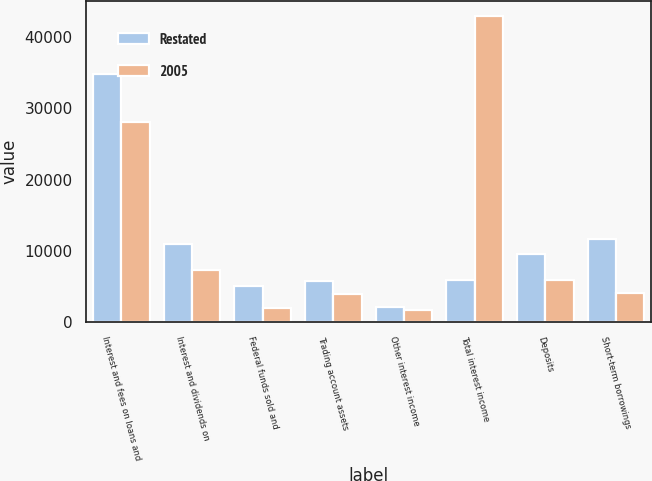<chart> <loc_0><loc_0><loc_500><loc_500><stacked_bar_chart><ecel><fcel>Interest and fees on loans and<fcel>Interest and dividends on<fcel>Federal funds sold and<fcel>Trading account assets<fcel>Other interest income<fcel>Total interest income<fcel>Deposits<fcel>Short-term borrowings<nl><fcel>Restated<fcel>34843<fcel>10937<fcel>5012<fcel>5743<fcel>2091<fcel>5921<fcel>9492<fcel>11615<nl><fcel>2005<fcel>28051<fcel>7256<fcel>1940<fcel>4016<fcel>1690<fcel>42953<fcel>5921<fcel>4072<nl></chart> 